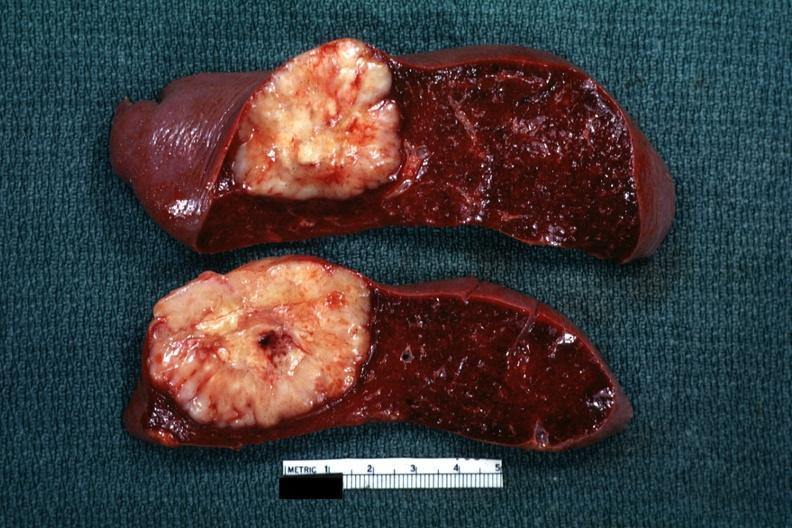s metastatic carcinoma lung present?
Answer the question using a single word or phrase. No 